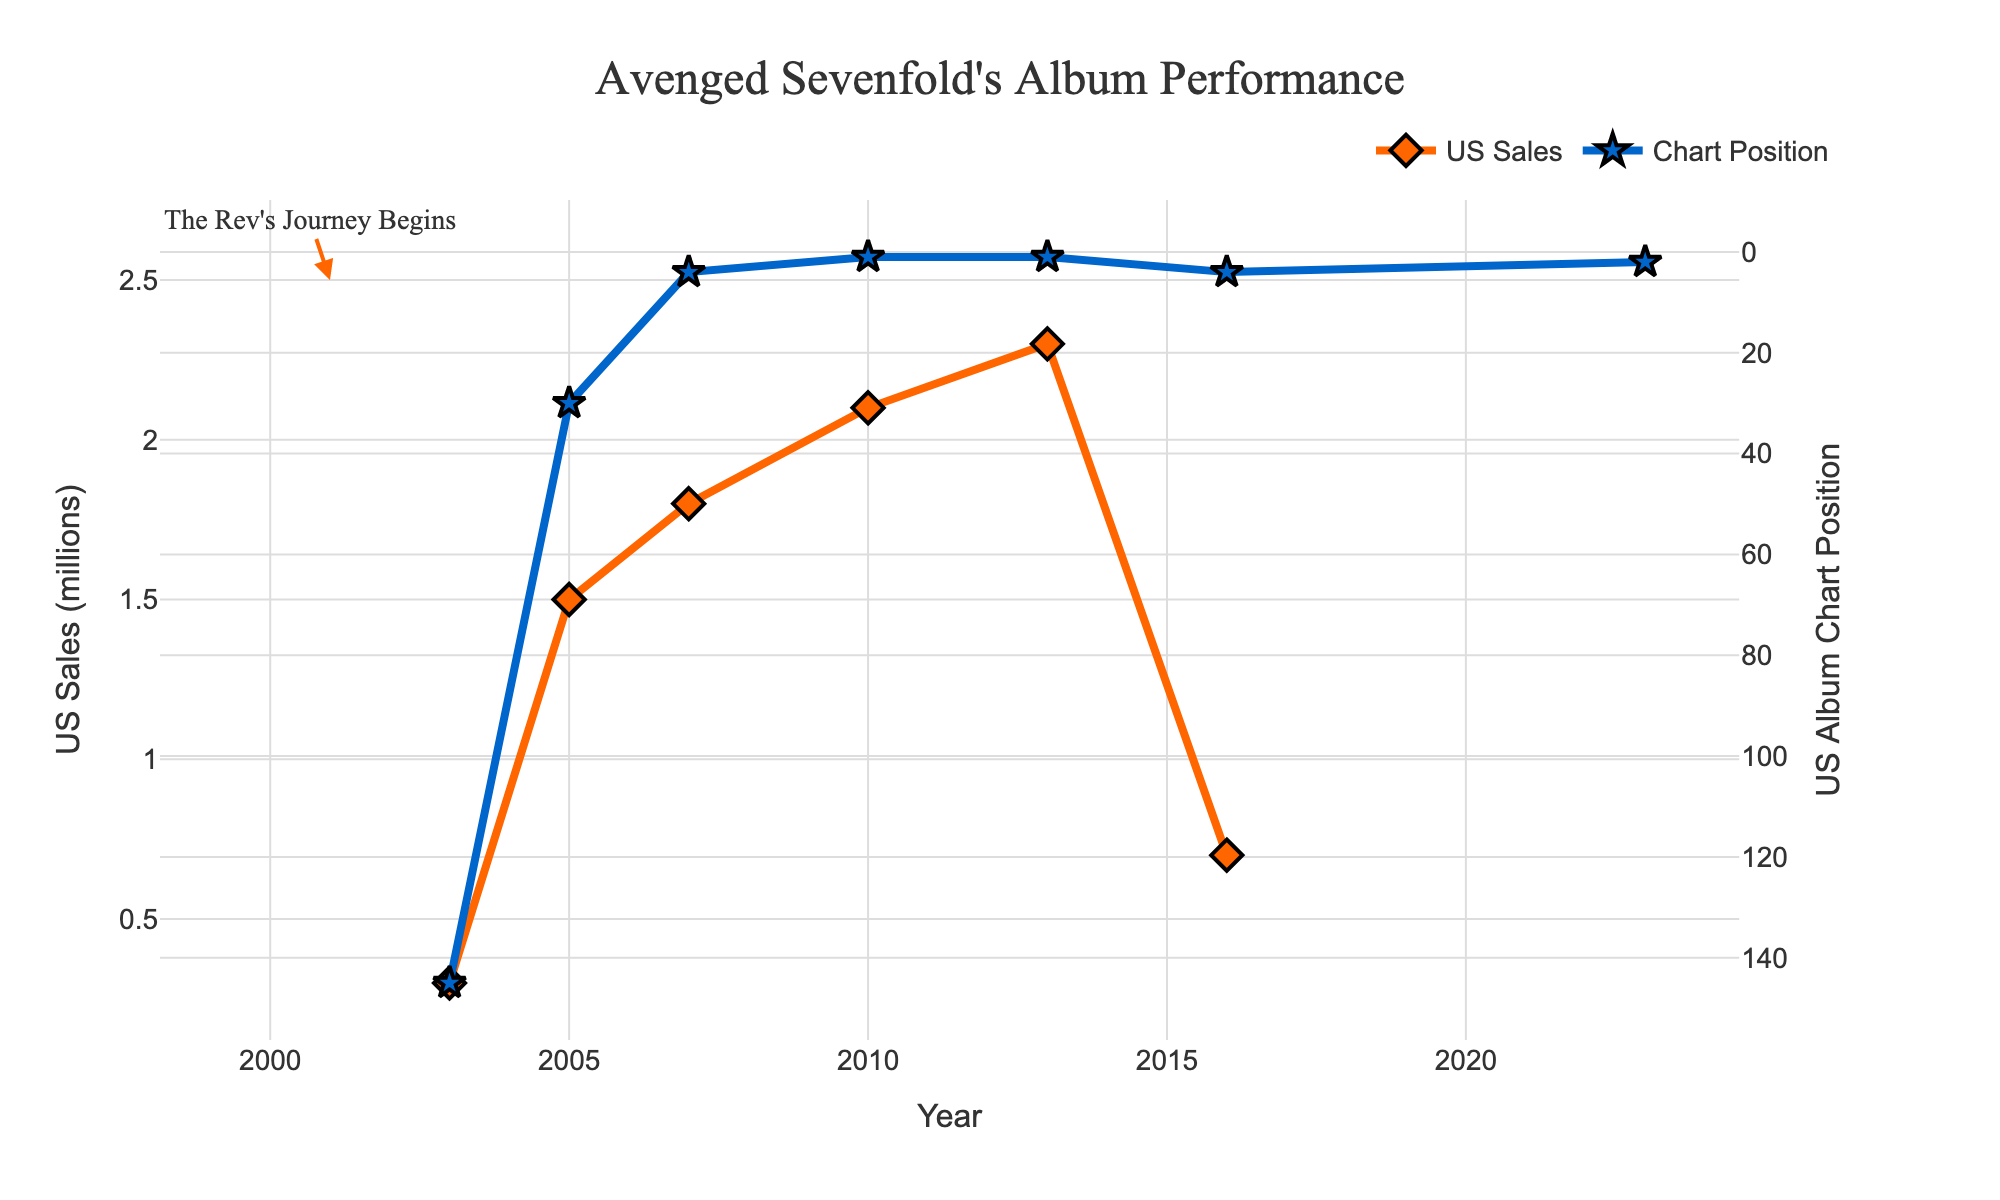What's the highest sales figure for an Avenged Sevenfold album? The US Sales (millions) line can be observed to see the point with the highest value. Nightmare and Hail to the King both reach this peak, but checking the numbers, Hail to the King slightly surpasses it at 2.3 million.
Answer: 2.3 million Which album reached the highest position on the US Album Chart? The Chart Position line can be observed to find the lowest value (since lower chart positions correspond to better performance). Both Nightmare and Hail to the King reached position 1.
Answer: Nightmare and Hail to the King How many albums reached the top 5 on the US Album Chart? By noting the points on the Chart Position line that are 5 or less, we see that Avenged Sevenfold (2007), Nightmare (2010), Hail to the King (2013), The Stage (2016), and Life Is but a Dream... (2023) all meet this criterion.
Answer: 5 Which album had the largest jump in US Album Chart Position compared to its previous album? Calculate the differences in Chart Positions between consecutive albums: Sounding the Seventh Trumpet to Waking the Fallen, Waking the Fallen to City of Evil, City of Evil to Avenged Sevenfold, etc. The jump from City of Evil (30) to Avenged Sevenfold (4) is the largest difference.
Answer: City of Evil to Avenged Sevenfold What is the average US Sales figure for the albums with a chart position? First, add all the sales figures (0.3 + 1.5 + 1.8 + 2.1 + 2.3 + 0.7) and then divide by the number of albums (7): (0.3 + 1.5 + 1.8 + 2.1 + 2.3 + 0.7 = 8.7)/(7) = 1.24 million.
Answer: 1.24 million Between which two albums did the US Sales increase the most? Compare the differences in the US Sales line between consecutive albums: Waking the Fallen to City of Evil (1.5 - 0.3 = 1.2), City of Evil to Avenged Sevenfold (1.8 - 1.5 = 0.3), Avenged Sevenfold to Nightmare (2.1 - 1.8 = 0.3), etc. The largest increase is from Waking the Fallen to City of Evil with 1.2 million.
Answer: Waking the Fallen to City of Evil Which album experienced a decline in US Sales compared to its predecessor? Observing the US Sales line, we notice that The Stage (0.7) sold fewer copies compared to Hail to the King (2.3), indicating a decline.
Answer: The Stage How many albums had Chart Positions better than 10? By identifying points on the Chart Position line with values less than 10: Avenged Sevenfold (4), Nightmare (1), Hail to the King (1), The Stage (4), and Life Is but a Dream... (2).
Answer: 5 What is the total US Sales for the albums released before Jimmy "The Rev" Sullivan passed away in 2009? Sum the sales figures of the albums released before 2009 (Waking the Fallen (0.3), City of Evil (1.5), Avenged Sevenfold (1.8)): 0.3 + 1.5 + 1.8 = 3.6 million.
Answer: 3.6 million Which album showed the highest US Album Chart Position improvement from its immediate predecessor? Calculate the change in the US Album Chart Position between each pair of consecutive albums: Waking the Fallen (145) to City of Evil (30), City of Evil (30) to Avenged Sevenfold (4), etc. The Avenged Sevenfold (4) after City of Evil (30) shows the greatest improvement, a difference of 26 positions.
Answer: Avenged Sevenfold 